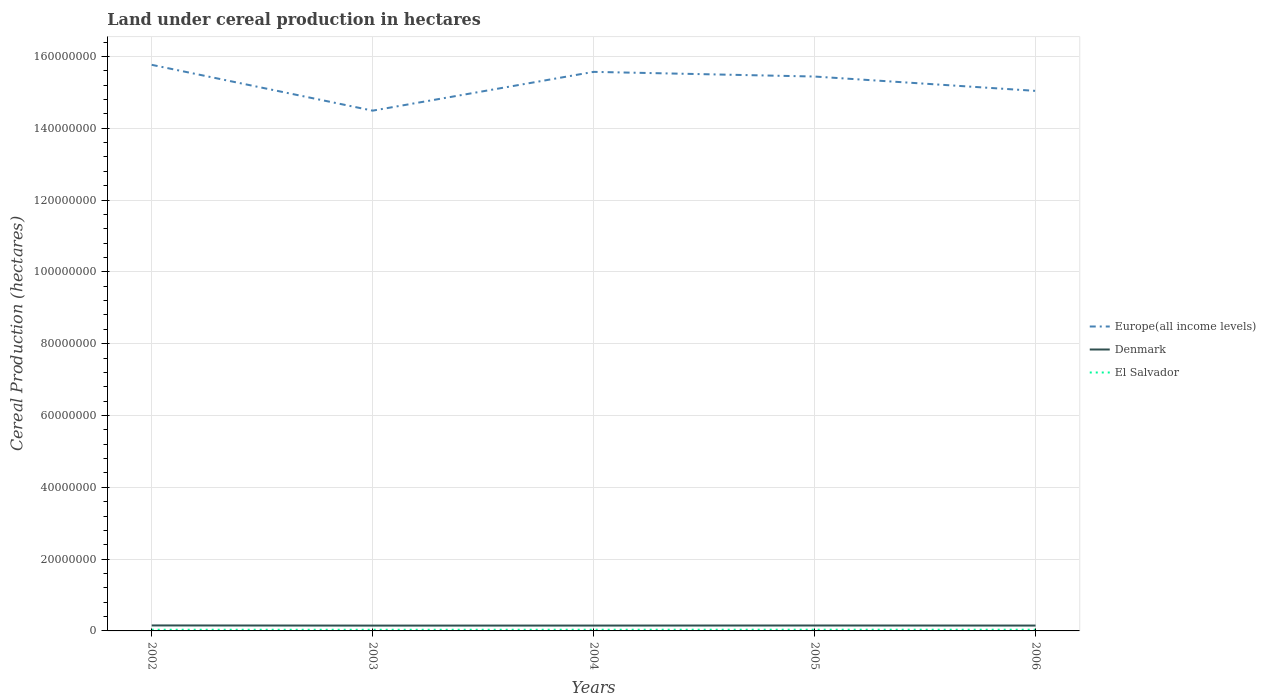How many different coloured lines are there?
Your answer should be very brief. 3. Across all years, what is the maximum land under cereal production in El Salvador?
Give a very brief answer. 3.20e+05. What is the total land under cereal production in Europe(all income levels) in the graph?
Give a very brief answer. -9.50e+06. What is the difference between the highest and the second highest land under cereal production in El Salvador?
Give a very brief answer. 1.98e+04. How many years are there in the graph?
Your answer should be compact. 5. Does the graph contain any zero values?
Your response must be concise. No. How many legend labels are there?
Your answer should be very brief. 3. How are the legend labels stacked?
Your response must be concise. Vertical. What is the title of the graph?
Give a very brief answer. Land under cereal production in hectares. What is the label or title of the Y-axis?
Offer a very short reply. Cereal Production (hectares). What is the Cereal Production (hectares) in Europe(all income levels) in 2002?
Give a very brief answer. 1.58e+08. What is the Cereal Production (hectares) in Denmark in 2002?
Offer a very short reply. 1.53e+06. What is the Cereal Production (hectares) of El Salvador in 2002?
Make the answer very short. 3.29e+05. What is the Cereal Production (hectares) of Europe(all income levels) in 2003?
Give a very brief answer. 1.45e+08. What is the Cereal Production (hectares) in Denmark in 2003?
Provide a succinct answer. 1.48e+06. What is the Cereal Production (hectares) in El Salvador in 2003?
Offer a very short reply. 3.20e+05. What is the Cereal Production (hectares) in Europe(all income levels) in 2004?
Ensure brevity in your answer.  1.56e+08. What is the Cereal Production (hectares) in Denmark in 2004?
Provide a short and direct response. 1.49e+06. What is the Cereal Production (hectares) of El Salvador in 2004?
Your response must be concise. 3.31e+05. What is the Cereal Production (hectares) in Europe(all income levels) in 2005?
Provide a succinct answer. 1.54e+08. What is the Cereal Production (hectares) in Denmark in 2005?
Give a very brief answer. 1.51e+06. What is the Cereal Production (hectares) in El Salvador in 2005?
Your answer should be very brief. 3.40e+05. What is the Cereal Production (hectares) of Europe(all income levels) in 2006?
Offer a terse response. 1.50e+08. What is the Cereal Production (hectares) in Denmark in 2006?
Offer a very short reply. 1.49e+06. What is the Cereal Production (hectares) of El Salvador in 2006?
Your answer should be compact. 3.34e+05. Across all years, what is the maximum Cereal Production (hectares) of Europe(all income levels)?
Offer a very short reply. 1.58e+08. Across all years, what is the maximum Cereal Production (hectares) of Denmark?
Keep it short and to the point. 1.53e+06. Across all years, what is the maximum Cereal Production (hectares) of El Salvador?
Your answer should be very brief. 3.40e+05. Across all years, what is the minimum Cereal Production (hectares) in Europe(all income levels)?
Ensure brevity in your answer.  1.45e+08. Across all years, what is the minimum Cereal Production (hectares) of Denmark?
Your answer should be very brief. 1.48e+06. Across all years, what is the minimum Cereal Production (hectares) of El Salvador?
Provide a short and direct response. 3.20e+05. What is the total Cereal Production (hectares) of Europe(all income levels) in the graph?
Your answer should be very brief. 7.63e+08. What is the total Cereal Production (hectares) of Denmark in the graph?
Provide a short and direct response. 7.51e+06. What is the total Cereal Production (hectares) of El Salvador in the graph?
Your answer should be compact. 1.65e+06. What is the difference between the Cereal Production (hectares) in Europe(all income levels) in 2002 and that in 2003?
Offer a very short reply. 1.28e+07. What is the difference between the Cereal Production (hectares) of Denmark in 2002 and that in 2003?
Your answer should be compact. 4.33e+04. What is the difference between the Cereal Production (hectares) of El Salvador in 2002 and that in 2003?
Give a very brief answer. 8624. What is the difference between the Cereal Production (hectares) in Europe(all income levels) in 2002 and that in 2004?
Make the answer very short. 1.96e+06. What is the difference between the Cereal Production (hectares) of Denmark in 2002 and that in 2004?
Your answer should be very brief. 3.73e+04. What is the difference between the Cereal Production (hectares) in El Salvador in 2002 and that in 2004?
Your answer should be compact. -1988. What is the difference between the Cereal Production (hectares) in Europe(all income levels) in 2002 and that in 2005?
Your response must be concise. 3.26e+06. What is the difference between the Cereal Production (hectares) of Denmark in 2002 and that in 2005?
Give a very brief answer. 1.93e+04. What is the difference between the Cereal Production (hectares) in El Salvador in 2002 and that in 2005?
Your answer should be compact. -1.12e+04. What is the difference between the Cereal Production (hectares) of Europe(all income levels) in 2002 and that in 2006?
Ensure brevity in your answer.  7.26e+06. What is the difference between the Cereal Production (hectares) of Denmark in 2002 and that in 2006?
Your response must be concise. 3.40e+04. What is the difference between the Cereal Production (hectares) of El Salvador in 2002 and that in 2006?
Provide a short and direct response. -5593. What is the difference between the Cereal Production (hectares) in Europe(all income levels) in 2003 and that in 2004?
Your response must be concise. -1.08e+07. What is the difference between the Cereal Production (hectares) in Denmark in 2003 and that in 2004?
Make the answer very short. -6014. What is the difference between the Cereal Production (hectares) in El Salvador in 2003 and that in 2004?
Keep it short and to the point. -1.06e+04. What is the difference between the Cereal Production (hectares) of Europe(all income levels) in 2003 and that in 2005?
Your answer should be very brief. -9.50e+06. What is the difference between the Cereal Production (hectares) of Denmark in 2003 and that in 2005?
Your response must be concise. -2.40e+04. What is the difference between the Cereal Production (hectares) of El Salvador in 2003 and that in 2005?
Offer a terse response. -1.98e+04. What is the difference between the Cereal Production (hectares) in Europe(all income levels) in 2003 and that in 2006?
Provide a short and direct response. -5.51e+06. What is the difference between the Cereal Production (hectares) in Denmark in 2003 and that in 2006?
Give a very brief answer. -9314. What is the difference between the Cereal Production (hectares) of El Salvador in 2003 and that in 2006?
Offer a terse response. -1.42e+04. What is the difference between the Cereal Production (hectares) in Europe(all income levels) in 2004 and that in 2005?
Your response must be concise. 1.30e+06. What is the difference between the Cereal Production (hectares) of Denmark in 2004 and that in 2005?
Provide a short and direct response. -1.80e+04. What is the difference between the Cereal Production (hectares) of El Salvador in 2004 and that in 2005?
Ensure brevity in your answer.  -9234. What is the difference between the Cereal Production (hectares) of Europe(all income levels) in 2004 and that in 2006?
Provide a succinct answer. 5.30e+06. What is the difference between the Cereal Production (hectares) in Denmark in 2004 and that in 2006?
Ensure brevity in your answer.  -3300. What is the difference between the Cereal Production (hectares) of El Salvador in 2004 and that in 2006?
Ensure brevity in your answer.  -3605. What is the difference between the Cereal Production (hectares) of Europe(all income levels) in 2005 and that in 2006?
Ensure brevity in your answer.  3.99e+06. What is the difference between the Cereal Production (hectares) of Denmark in 2005 and that in 2006?
Your response must be concise. 1.47e+04. What is the difference between the Cereal Production (hectares) of El Salvador in 2005 and that in 2006?
Your response must be concise. 5629. What is the difference between the Cereal Production (hectares) of Europe(all income levels) in 2002 and the Cereal Production (hectares) of Denmark in 2003?
Ensure brevity in your answer.  1.56e+08. What is the difference between the Cereal Production (hectares) of Europe(all income levels) in 2002 and the Cereal Production (hectares) of El Salvador in 2003?
Give a very brief answer. 1.57e+08. What is the difference between the Cereal Production (hectares) of Denmark in 2002 and the Cereal Production (hectares) of El Salvador in 2003?
Provide a succinct answer. 1.21e+06. What is the difference between the Cereal Production (hectares) of Europe(all income levels) in 2002 and the Cereal Production (hectares) of Denmark in 2004?
Keep it short and to the point. 1.56e+08. What is the difference between the Cereal Production (hectares) of Europe(all income levels) in 2002 and the Cereal Production (hectares) of El Salvador in 2004?
Give a very brief answer. 1.57e+08. What is the difference between the Cereal Production (hectares) of Denmark in 2002 and the Cereal Production (hectares) of El Salvador in 2004?
Provide a short and direct response. 1.20e+06. What is the difference between the Cereal Production (hectares) in Europe(all income levels) in 2002 and the Cereal Production (hectares) in Denmark in 2005?
Make the answer very short. 1.56e+08. What is the difference between the Cereal Production (hectares) of Europe(all income levels) in 2002 and the Cereal Production (hectares) of El Salvador in 2005?
Give a very brief answer. 1.57e+08. What is the difference between the Cereal Production (hectares) of Denmark in 2002 and the Cereal Production (hectares) of El Salvador in 2005?
Make the answer very short. 1.19e+06. What is the difference between the Cereal Production (hectares) of Europe(all income levels) in 2002 and the Cereal Production (hectares) of Denmark in 2006?
Ensure brevity in your answer.  1.56e+08. What is the difference between the Cereal Production (hectares) of Europe(all income levels) in 2002 and the Cereal Production (hectares) of El Salvador in 2006?
Your answer should be compact. 1.57e+08. What is the difference between the Cereal Production (hectares) of Denmark in 2002 and the Cereal Production (hectares) of El Salvador in 2006?
Offer a terse response. 1.19e+06. What is the difference between the Cereal Production (hectares) of Europe(all income levels) in 2003 and the Cereal Production (hectares) of Denmark in 2004?
Your response must be concise. 1.43e+08. What is the difference between the Cereal Production (hectares) of Europe(all income levels) in 2003 and the Cereal Production (hectares) of El Salvador in 2004?
Provide a succinct answer. 1.45e+08. What is the difference between the Cereal Production (hectares) in Denmark in 2003 and the Cereal Production (hectares) in El Salvador in 2004?
Your answer should be compact. 1.15e+06. What is the difference between the Cereal Production (hectares) of Europe(all income levels) in 2003 and the Cereal Production (hectares) of Denmark in 2005?
Offer a terse response. 1.43e+08. What is the difference between the Cereal Production (hectares) of Europe(all income levels) in 2003 and the Cereal Production (hectares) of El Salvador in 2005?
Offer a terse response. 1.45e+08. What is the difference between the Cereal Production (hectares) in Denmark in 2003 and the Cereal Production (hectares) in El Salvador in 2005?
Your response must be concise. 1.14e+06. What is the difference between the Cereal Production (hectares) of Europe(all income levels) in 2003 and the Cereal Production (hectares) of Denmark in 2006?
Provide a short and direct response. 1.43e+08. What is the difference between the Cereal Production (hectares) in Europe(all income levels) in 2003 and the Cereal Production (hectares) in El Salvador in 2006?
Your response must be concise. 1.45e+08. What is the difference between the Cereal Production (hectares) of Denmark in 2003 and the Cereal Production (hectares) of El Salvador in 2006?
Make the answer very short. 1.15e+06. What is the difference between the Cereal Production (hectares) of Europe(all income levels) in 2004 and the Cereal Production (hectares) of Denmark in 2005?
Offer a very short reply. 1.54e+08. What is the difference between the Cereal Production (hectares) of Europe(all income levels) in 2004 and the Cereal Production (hectares) of El Salvador in 2005?
Offer a very short reply. 1.55e+08. What is the difference between the Cereal Production (hectares) of Denmark in 2004 and the Cereal Production (hectares) of El Salvador in 2005?
Provide a short and direct response. 1.15e+06. What is the difference between the Cereal Production (hectares) in Europe(all income levels) in 2004 and the Cereal Production (hectares) in Denmark in 2006?
Offer a very short reply. 1.54e+08. What is the difference between the Cereal Production (hectares) in Europe(all income levels) in 2004 and the Cereal Production (hectares) in El Salvador in 2006?
Your answer should be compact. 1.55e+08. What is the difference between the Cereal Production (hectares) in Denmark in 2004 and the Cereal Production (hectares) in El Salvador in 2006?
Ensure brevity in your answer.  1.16e+06. What is the difference between the Cereal Production (hectares) in Europe(all income levels) in 2005 and the Cereal Production (hectares) in Denmark in 2006?
Offer a terse response. 1.53e+08. What is the difference between the Cereal Production (hectares) in Europe(all income levels) in 2005 and the Cereal Production (hectares) in El Salvador in 2006?
Your answer should be compact. 1.54e+08. What is the difference between the Cereal Production (hectares) in Denmark in 2005 and the Cereal Production (hectares) in El Salvador in 2006?
Provide a succinct answer. 1.17e+06. What is the average Cereal Production (hectares) in Europe(all income levels) per year?
Your answer should be very brief. 1.53e+08. What is the average Cereal Production (hectares) in Denmark per year?
Offer a very short reply. 1.50e+06. What is the average Cereal Production (hectares) in El Salvador per year?
Give a very brief answer. 3.31e+05. In the year 2002, what is the difference between the Cereal Production (hectares) of Europe(all income levels) and Cereal Production (hectares) of Denmark?
Keep it short and to the point. 1.56e+08. In the year 2002, what is the difference between the Cereal Production (hectares) in Europe(all income levels) and Cereal Production (hectares) in El Salvador?
Provide a short and direct response. 1.57e+08. In the year 2002, what is the difference between the Cereal Production (hectares) in Denmark and Cereal Production (hectares) in El Salvador?
Your answer should be very brief. 1.20e+06. In the year 2003, what is the difference between the Cereal Production (hectares) in Europe(all income levels) and Cereal Production (hectares) in Denmark?
Your answer should be compact. 1.43e+08. In the year 2003, what is the difference between the Cereal Production (hectares) of Europe(all income levels) and Cereal Production (hectares) of El Salvador?
Your answer should be very brief. 1.45e+08. In the year 2003, what is the difference between the Cereal Production (hectares) of Denmark and Cereal Production (hectares) of El Salvador?
Make the answer very short. 1.16e+06. In the year 2004, what is the difference between the Cereal Production (hectares) of Europe(all income levels) and Cereal Production (hectares) of Denmark?
Provide a succinct answer. 1.54e+08. In the year 2004, what is the difference between the Cereal Production (hectares) in Europe(all income levels) and Cereal Production (hectares) in El Salvador?
Offer a very short reply. 1.55e+08. In the year 2004, what is the difference between the Cereal Production (hectares) of Denmark and Cereal Production (hectares) of El Salvador?
Your answer should be compact. 1.16e+06. In the year 2005, what is the difference between the Cereal Production (hectares) of Europe(all income levels) and Cereal Production (hectares) of Denmark?
Ensure brevity in your answer.  1.53e+08. In the year 2005, what is the difference between the Cereal Production (hectares) of Europe(all income levels) and Cereal Production (hectares) of El Salvador?
Make the answer very short. 1.54e+08. In the year 2005, what is the difference between the Cereal Production (hectares) of Denmark and Cereal Production (hectares) of El Salvador?
Provide a short and direct response. 1.17e+06. In the year 2006, what is the difference between the Cereal Production (hectares) in Europe(all income levels) and Cereal Production (hectares) in Denmark?
Make the answer very short. 1.49e+08. In the year 2006, what is the difference between the Cereal Production (hectares) of Europe(all income levels) and Cereal Production (hectares) of El Salvador?
Make the answer very short. 1.50e+08. In the year 2006, what is the difference between the Cereal Production (hectares) in Denmark and Cereal Production (hectares) in El Salvador?
Give a very brief answer. 1.16e+06. What is the ratio of the Cereal Production (hectares) of Europe(all income levels) in 2002 to that in 2003?
Provide a short and direct response. 1.09. What is the ratio of the Cereal Production (hectares) of Denmark in 2002 to that in 2003?
Make the answer very short. 1.03. What is the ratio of the Cereal Production (hectares) in El Salvador in 2002 to that in 2003?
Make the answer very short. 1.03. What is the ratio of the Cereal Production (hectares) in Europe(all income levels) in 2002 to that in 2004?
Give a very brief answer. 1.01. What is the ratio of the Cereal Production (hectares) in Europe(all income levels) in 2002 to that in 2005?
Your response must be concise. 1.02. What is the ratio of the Cereal Production (hectares) in Denmark in 2002 to that in 2005?
Your answer should be very brief. 1.01. What is the ratio of the Cereal Production (hectares) of Europe(all income levels) in 2002 to that in 2006?
Provide a succinct answer. 1.05. What is the ratio of the Cereal Production (hectares) of Denmark in 2002 to that in 2006?
Keep it short and to the point. 1.02. What is the ratio of the Cereal Production (hectares) of El Salvador in 2002 to that in 2006?
Offer a terse response. 0.98. What is the ratio of the Cereal Production (hectares) of Europe(all income levels) in 2003 to that in 2004?
Provide a short and direct response. 0.93. What is the ratio of the Cereal Production (hectares) of El Salvador in 2003 to that in 2004?
Offer a terse response. 0.97. What is the ratio of the Cereal Production (hectares) in Europe(all income levels) in 2003 to that in 2005?
Ensure brevity in your answer.  0.94. What is the ratio of the Cereal Production (hectares) of Denmark in 2003 to that in 2005?
Keep it short and to the point. 0.98. What is the ratio of the Cereal Production (hectares) in El Salvador in 2003 to that in 2005?
Provide a short and direct response. 0.94. What is the ratio of the Cereal Production (hectares) in Europe(all income levels) in 2003 to that in 2006?
Keep it short and to the point. 0.96. What is the ratio of the Cereal Production (hectares) in Denmark in 2003 to that in 2006?
Your answer should be very brief. 0.99. What is the ratio of the Cereal Production (hectares) of El Salvador in 2003 to that in 2006?
Offer a very short reply. 0.96. What is the ratio of the Cereal Production (hectares) in Europe(all income levels) in 2004 to that in 2005?
Make the answer very short. 1.01. What is the ratio of the Cereal Production (hectares) in El Salvador in 2004 to that in 2005?
Make the answer very short. 0.97. What is the ratio of the Cereal Production (hectares) of Europe(all income levels) in 2004 to that in 2006?
Give a very brief answer. 1.04. What is the ratio of the Cereal Production (hectares) of Denmark in 2004 to that in 2006?
Provide a succinct answer. 1. What is the ratio of the Cereal Production (hectares) of El Salvador in 2004 to that in 2006?
Give a very brief answer. 0.99. What is the ratio of the Cereal Production (hectares) in Europe(all income levels) in 2005 to that in 2006?
Your answer should be compact. 1.03. What is the ratio of the Cereal Production (hectares) of Denmark in 2005 to that in 2006?
Offer a terse response. 1.01. What is the ratio of the Cereal Production (hectares) in El Salvador in 2005 to that in 2006?
Your answer should be compact. 1.02. What is the difference between the highest and the second highest Cereal Production (hectares) in Europe(all income levels)?
Offer a very short reply. 1.96e+06. What is the difference between the highest and the second highest Cereal Production (hectares) in Denmark?
Ensure brevity in your answer.  1.93e+04. What is the difference between the highest and the second highest Cereal Production (hectares) of El Salvador?
Your answer should be compact. 5629. What is the difference between the highest and the lowest Cereal Production (hectares) in Europe(all income levels)?
Offer a terse response. 1.28e+07. What is the difference between the highest and the lowest Cereal Production (hectares) in Denmark?
Offer a terse response. 4.33e+04. What is the difference between the highest and the lowest Cereal Production (hectares) of El Salvador?
Keep it short and to the point. 1.98e+04. 